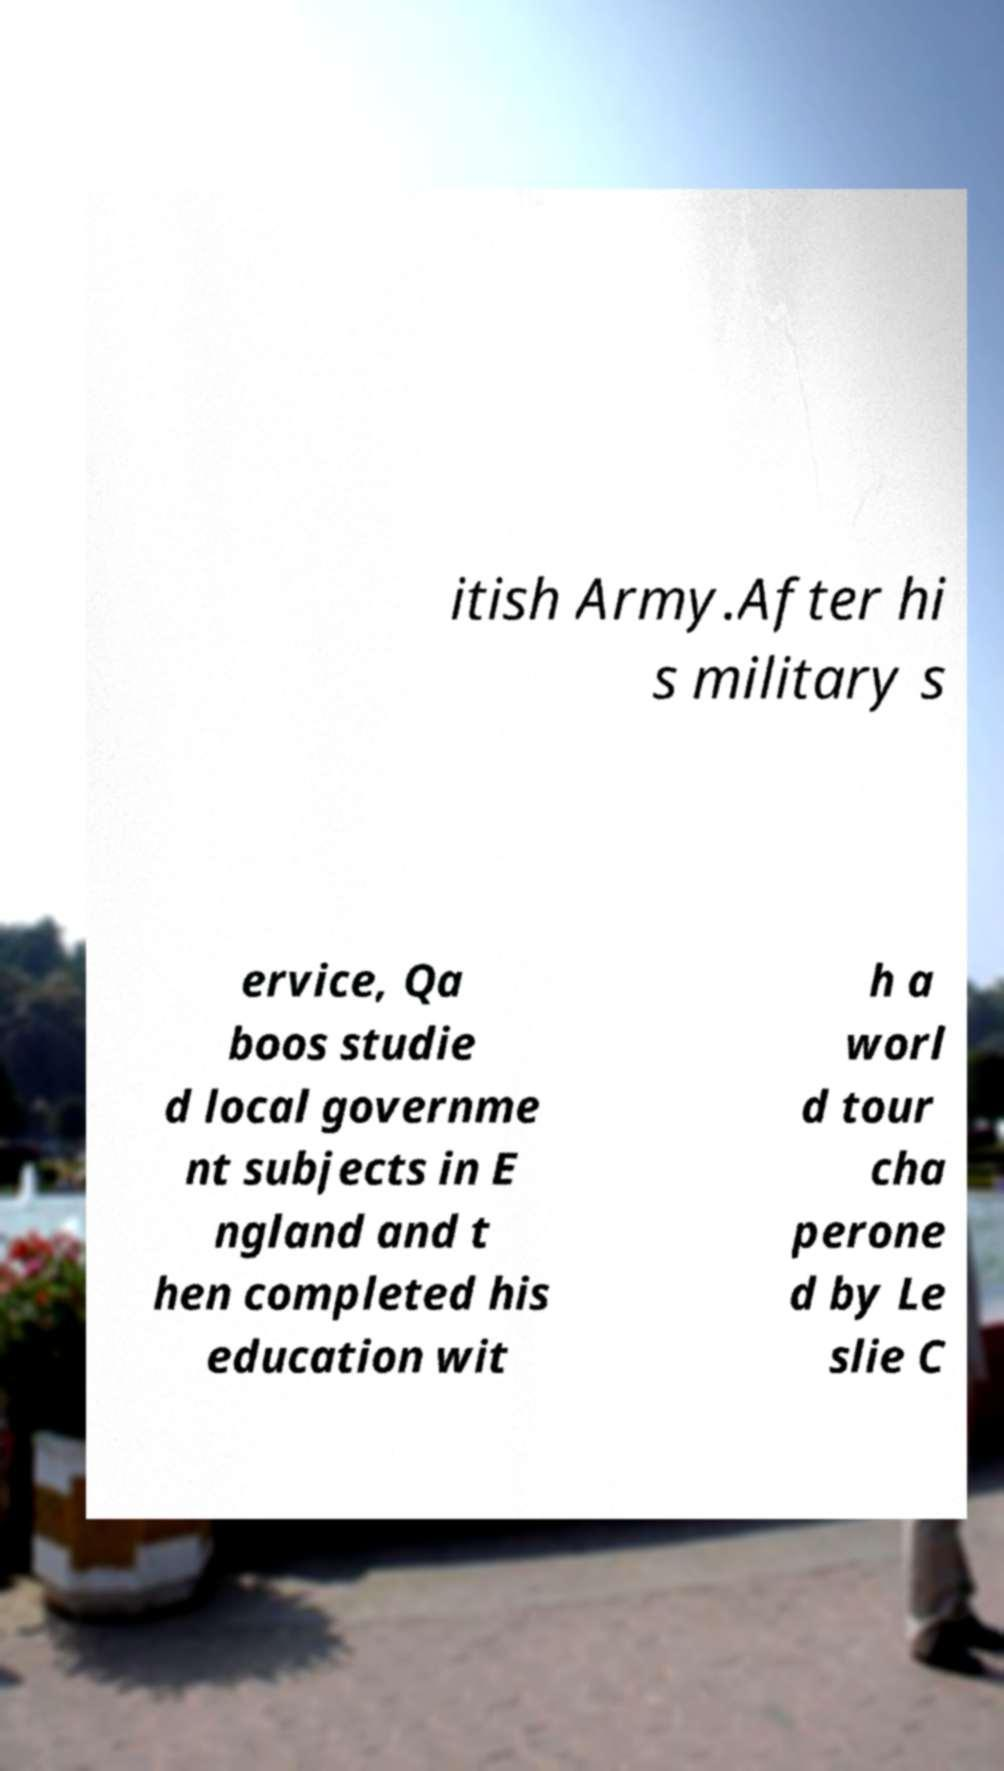Please identify and transcribe the text found in this image. itish Army.After hi s military s ervice, Qa boos studie d local governme nt subjects in E ngland and t hen completed his education wit h a worl d tour cha perone d by Le slie C 